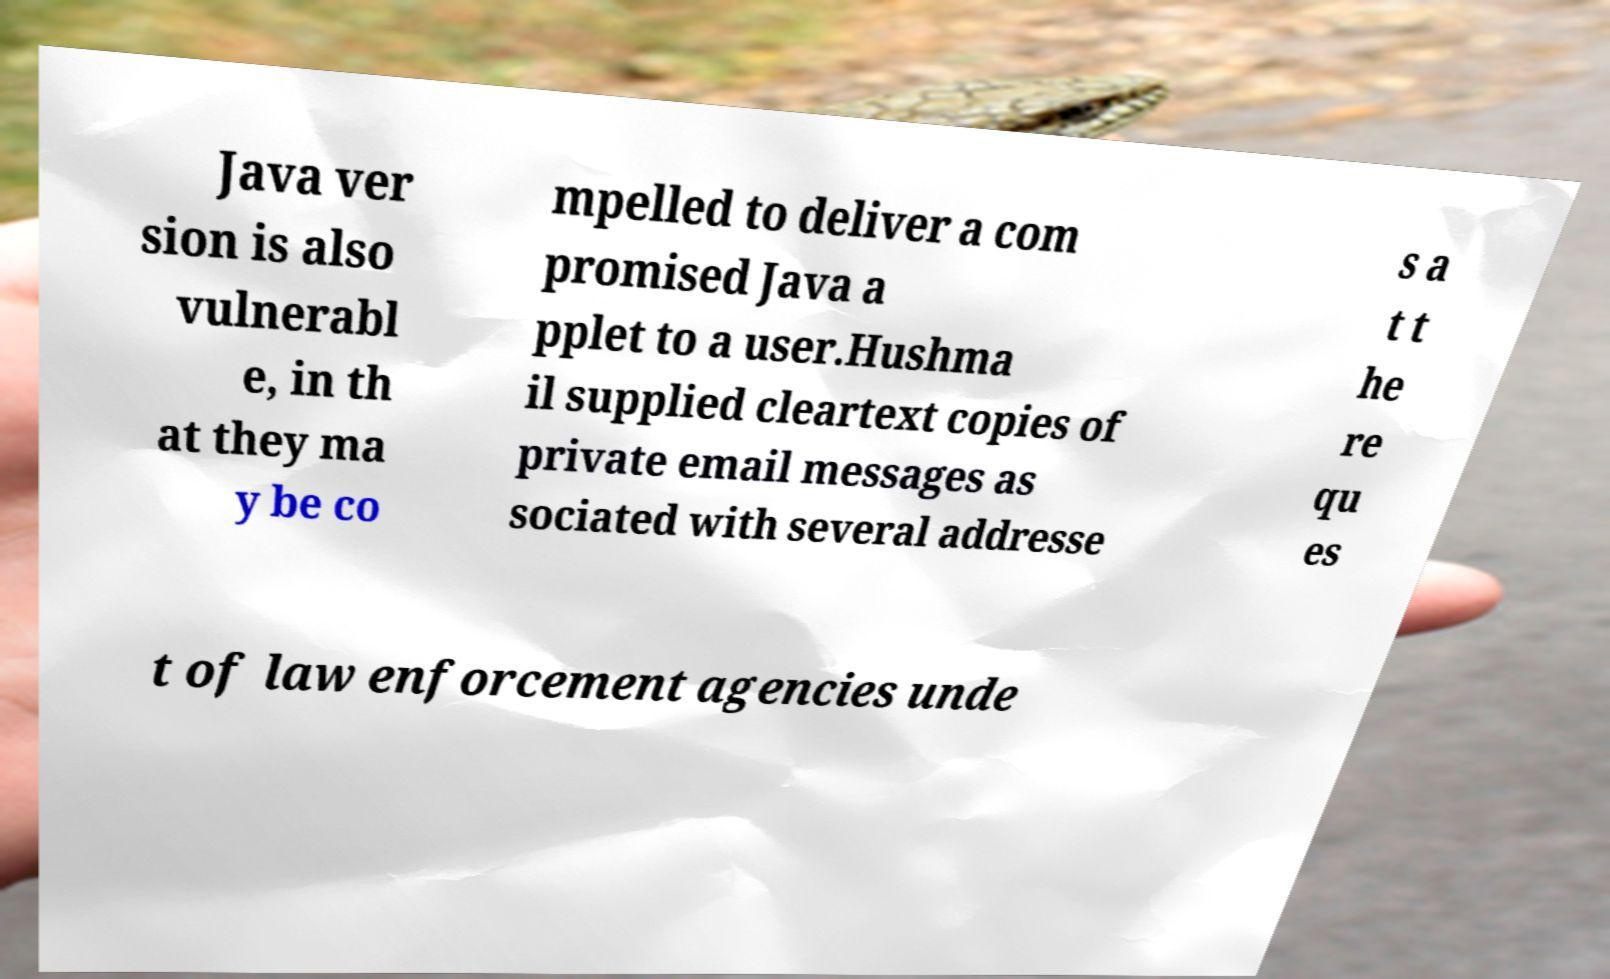There's text embedded in this image that I need extracted. Can you transcribe it verbatim? Java ver sion is also vulnerabl e, in th at they ma y be co mpelled to deliver a com promised Java a pplet to a user.Hushma il supplied cleartext copies of private email messages as sociated with several addresse s a t t he re qu es t of law enforcement agencies unde 